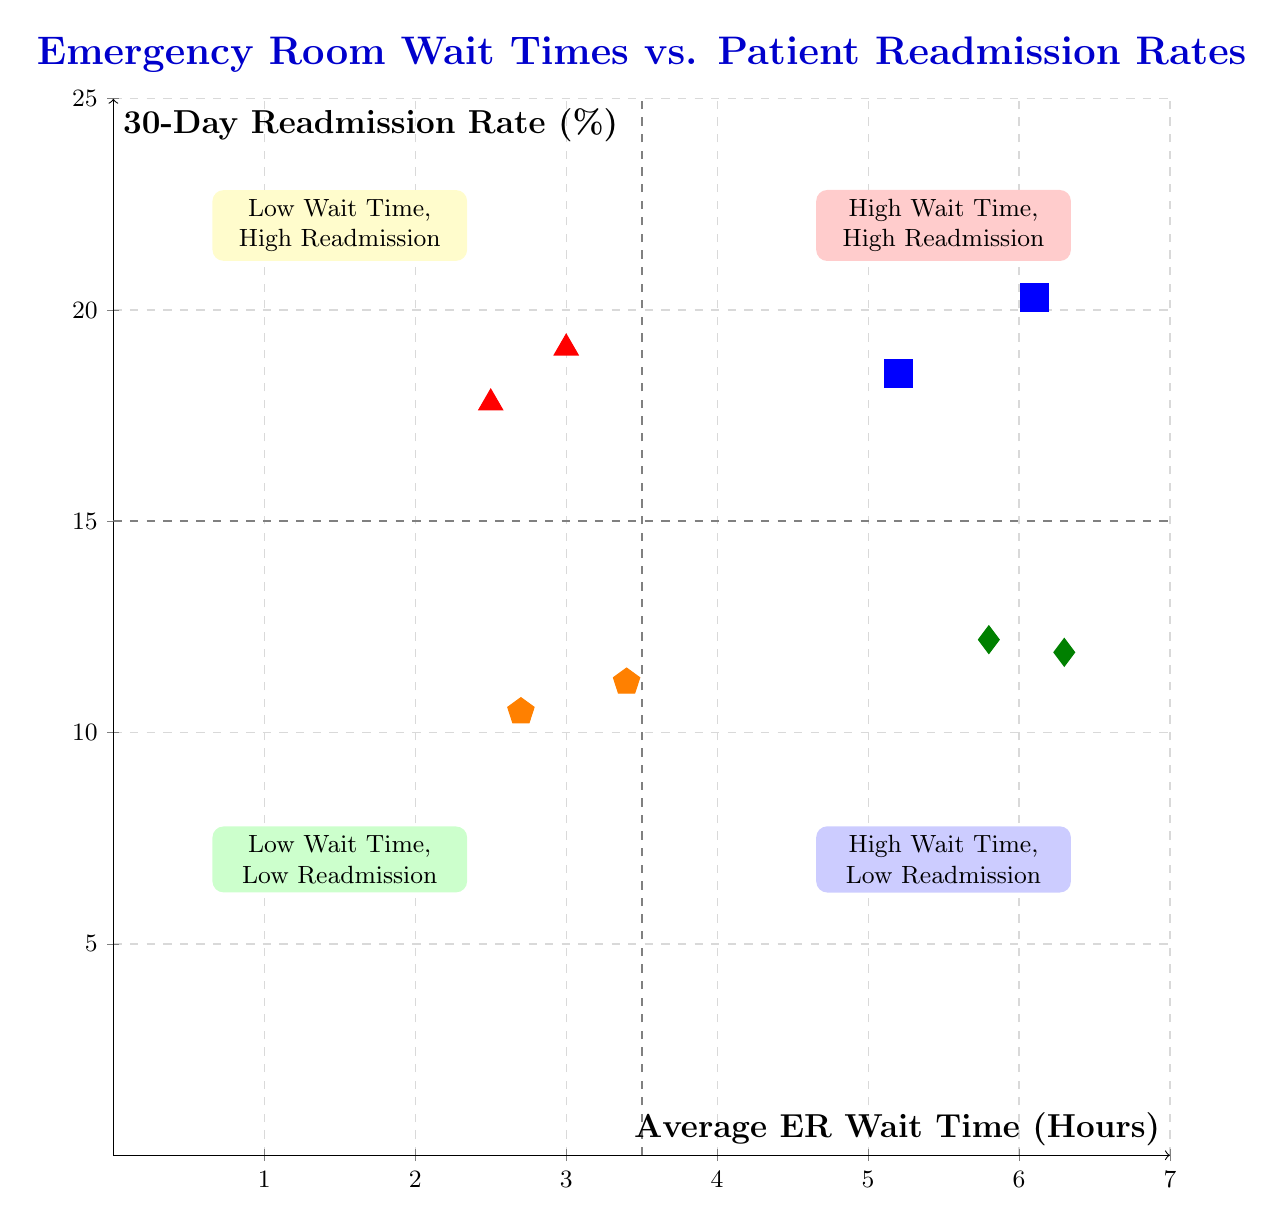What is the average ER wait time for General Hospital? The diagram shows that General Hospital has an average ER wait time of 5.2 hours, which is denoted by its position in the high wait time, high readmission quadrant.
Answer: 5.2 hours What is the 30-day readmission rate for Suburban Health Clinic? In the diagram, Suburban Health Clinic is located in the low wait time, low readmission quadrant and shows a readmission rate of 11.2%.
Answer: 11.2% How many hospitals are in the top right quadrant? The top right quadrant, labeled as high wait time and high readmission, includes two hospitals: General Hospital and City Medical Center. Therefore, there are two hospitals in this quadrant.
Answer: 2 Which strategies are suggested for hospitals in the low wait time, high readmission quadrant? The strategies provided for hospitals in this quadrant include improving discharge planning and enhancing follow-up care. These are specifically aimed at addressing high readmission rates despite low wait times.
Answer: Improve Discharge Planning, Enhance Follow-Up Care Which quadrant has the lowest readmission rate? The bottom left quadrant, labeled as low wait time and low readmission, exhibits the lowest readmission rates among all quadrants. The readmission rate for Downtown Medical is 10.5%, the lowest shown in the diagram.
Answer: Low Wait Time, Low Readmission What is the readmission rate for Lakeview Hospital? In the diagram, Lakeview Hospital is found in the bottom right quadrant, which corresponds to high wait time and low readmission, showing a readmission rate of 11.9%.
Answer: 11.9% Which hospital has the highest average ER wait time? The data in the diagram shows that City Medical Center has the highest average ER wait time at 6.1 hours, placing it within the high wait time, high readmission quadrant.
Answer: 6.1 hours What two strategies are suggested for the bottom right quadrant? For hospitals in the bottom right quadrant (high wait time, low readmission), the suggested strategies are to expedite diagnostic testing and increase bed availability, which can help improve overall ER efficiency.
Answer: Expedite Diagnostic Testing, Increase Bed Availability How does the average wait time correlate with readmission rates in the top left quadrant? In the top left quadrant, both hospitals (Regional Health Services and Community Hospital) show a low average wait time but relatively high readmission rates, indicating that longer wait times may not directly correlate to readmissions in this segment.
Answer: Low Wait Time, High Readmission 